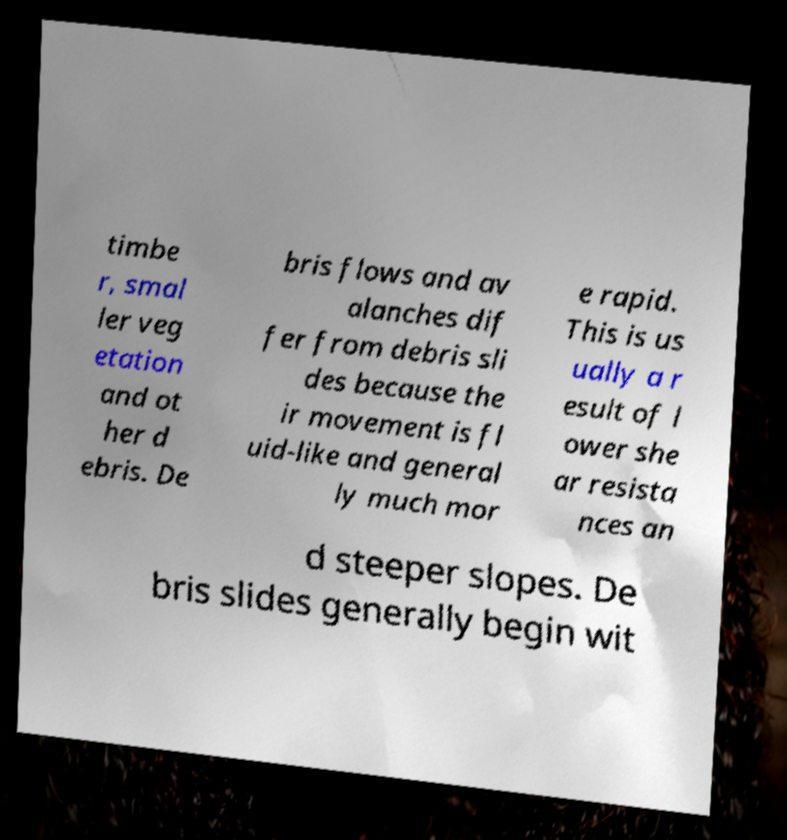Could you assist in decoding the text presented in this image and type it out clearly? timbe r, smal ler veg etation and ot her d ebris. De bris flows and av alanches dif fer from debris sli des because the ir movement is fl uid-like and general ly much mor e rapid. This is us ually a r esult of l ower she ar resista nces an d steeper slopes. De bris slides generally begin wit 